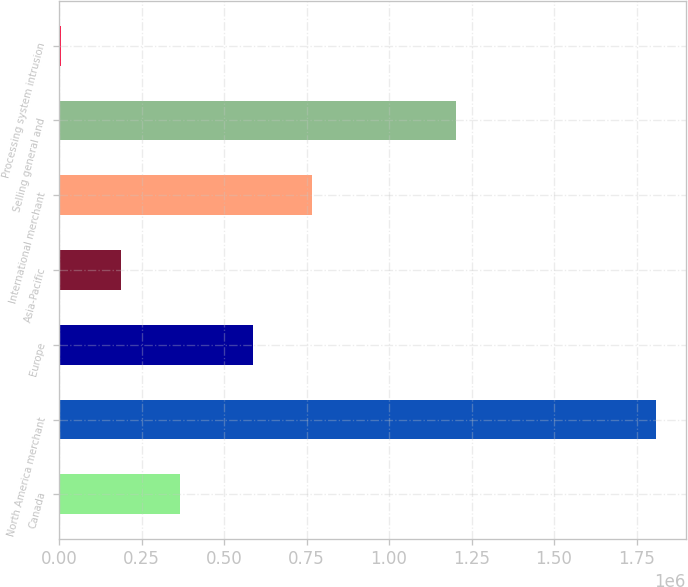Convert chart. <chart><loc_0><loc_0><loc_500><loc_500><bar_chart><fcel>Canada<fcel>North America merchant<fcel>Europe<fcel>Asia-Pacific<fcel>International merchant<fcel>Selling general and<fcel>Processing system intrusion<nl><fcel>367398<fcel>1.80899e+06<fcel>587463<fcel>187199<fcel>767662<fcel>1.20351e+06<fcel>7000<nl></chart> 